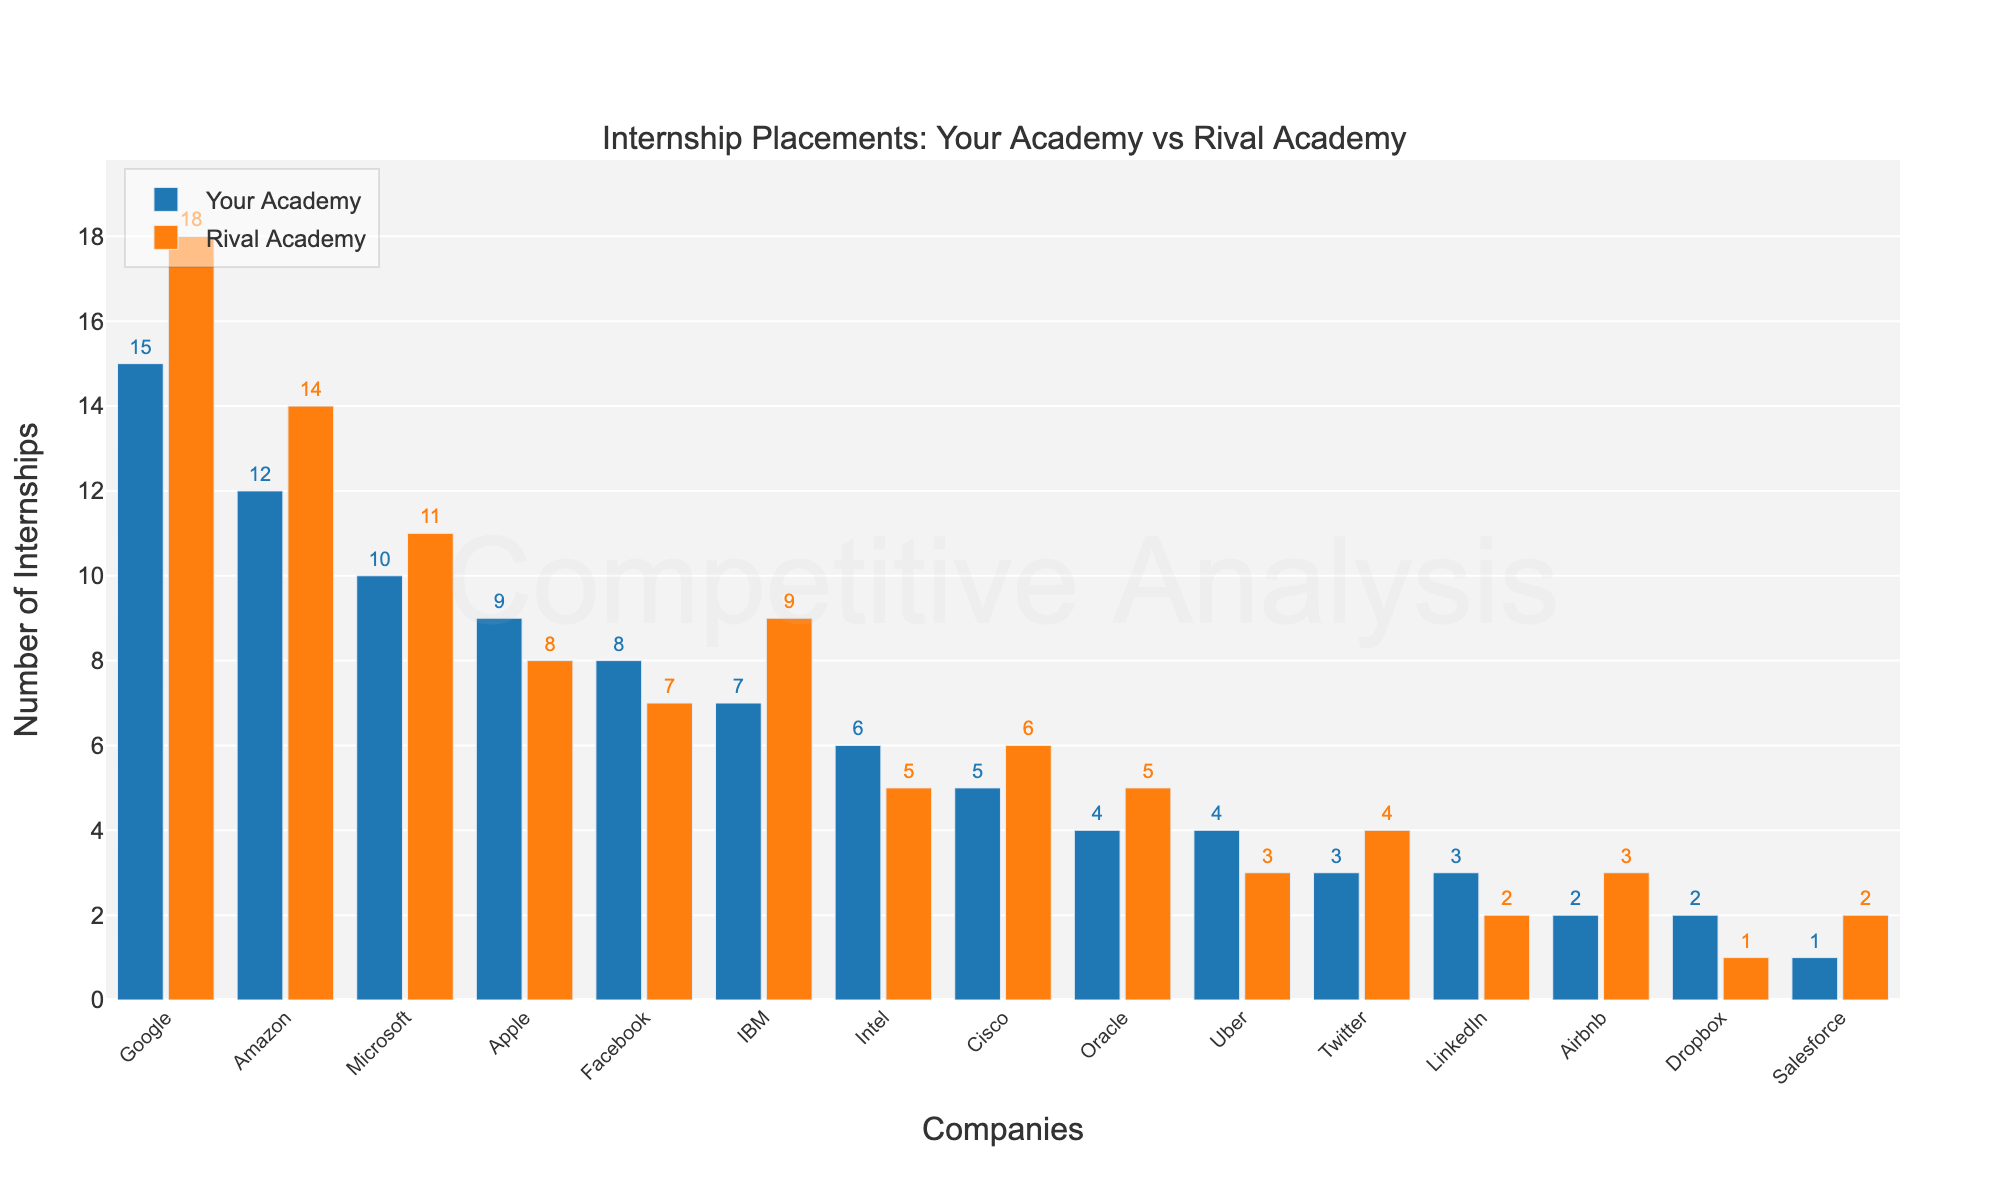Which company awarded more internships to Your Academy compared to the Rival Academy, and by how many? First, identify the companies where Your Academy has more internships than the Rival Academy. Google (3 more: 15 vs. 18), Apple (1 more: 9 vs. 8), Facebook (1 more: 8 vs. 7), Intel (1 more: 6 vs. 5), Uber (1 more: 4 vs. 3), and LinkedIn (1 more: 3 vs. 2). The largest margin is from Google.
Answer: Google by 3 What is the total number of internships provided by Amazon, Microsoft, and Facebook to Rival Academy? Add the numbers of internships from Amazon, Microsoft, and Facebook for Rival Academy: 14 (Amazon) + 11 (Microsoft) + 7 (Facebook) = 32.
Answer: 32 Compare the total number of internships from Intel, Cisco, and Oracle for Your Academy with that of the Rival Academy. Which institution received more? First, calculate the sum for Your Academy: 6 (Intel) + 5 (Cisco) + 4 (Oracle) = 15. Then, for Rival Academy: 5 (Intel) + 6 (Cisco) + 5 (Oracle) = 16. Rival Academy is higher.
Answer: Rival Academy Which company has the smallest difference in the number of internships between Your Academy and Rival Academy, and what is that difference? Calculate the difference for each company. The smallest difference is for companies like Apple (1), Facebook (1), Intel (1), Uber (1) and LinkedIn (1). The smallest difference is 1.
Answer: Apple, Facebook, Intel, Uber, and LinkedIn by 1 What is the average number of internships for Google, Amazon, and Microsoft at Your Academy? The total internships for Google, Amazon, and Microsoft at Your Academy are 15, 12, and 10, respectively. The average is (15 + 12 + 10)/3 = 37/3 = 12.33.
Answer: 12.33 Which company awarded the fewest internships to Your Academy? Reviewing the numbers, Salesforce awarded the fewest with 1 internship to Your Academy.
Answer: Salesforce By how many internships does Google exceed Airbnb in Your Academy? Google has 15 internships and Airbnb has 2. The difference is 15 - 2 = 13.
Answer: 13 What are the total internships awarded by IBM and Twitter for both academies? For Your Academy and Rival Academy, IBM is 7 and 9, respectively. Twitter is 3 and 4, respectively. Total is (7 + 9) + (3 + 4) = 23.
Answer: 23 Which academy received more internships overall from Cisco? Cisco has 5 internships for Your Academy and 6 for Rival Academy. Rival Academy has more.
Answer: Rival Academy 